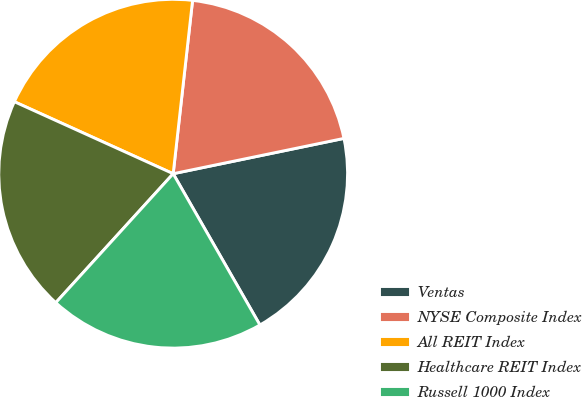Convert chart. <chart><loc_0><loc_0><loc_500><loc_500><pie_chart><fcel>Ventas<fcel>NYSE Composite Index<fcel>All REIT Index<fcel>Healthcare REIT Index<fcel>Russell 1000 Index<nl><fcel>19.96%<fcel>19.98%<fcel>20.0%<fcel>20.02%<fcel>20.04%<nl></chart> 